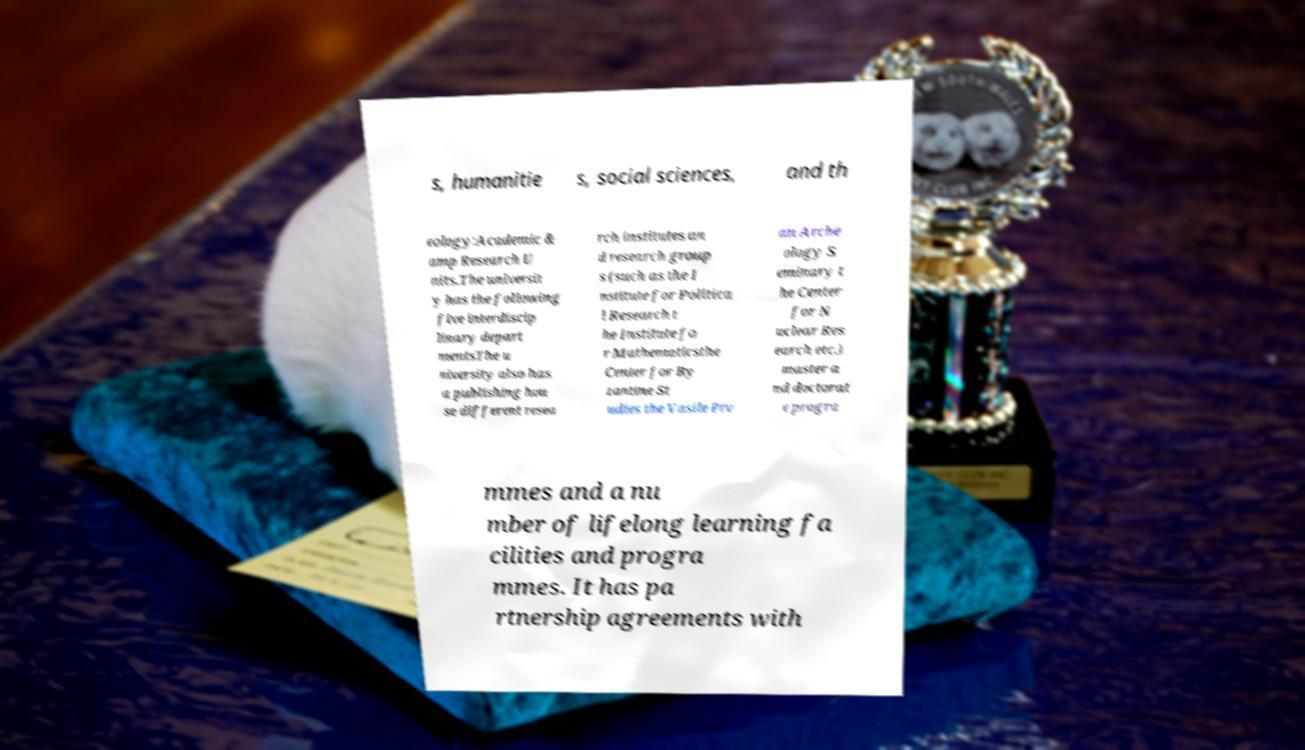Could you extract and type out the text from this image? s, humanitie s, social sciences, and th eology:Academic & amp Research U nits.The universit y has the following five interdiscip linary depart mentsThe u niversity also has a publishing hou se different resea rch institutes an d research group s (such as the I nstitute for Politica l Research t he Institute fo r Mathematicsthe Center for By zantine St udies the Vasile Prv an Arche ology S eminary t he Center for N uclear Res earch etc.) master a nd doctorat e progra mmes and a nu mber of lifelong learning fa cilities and progra mmes. It has pa rtnership agreements with 